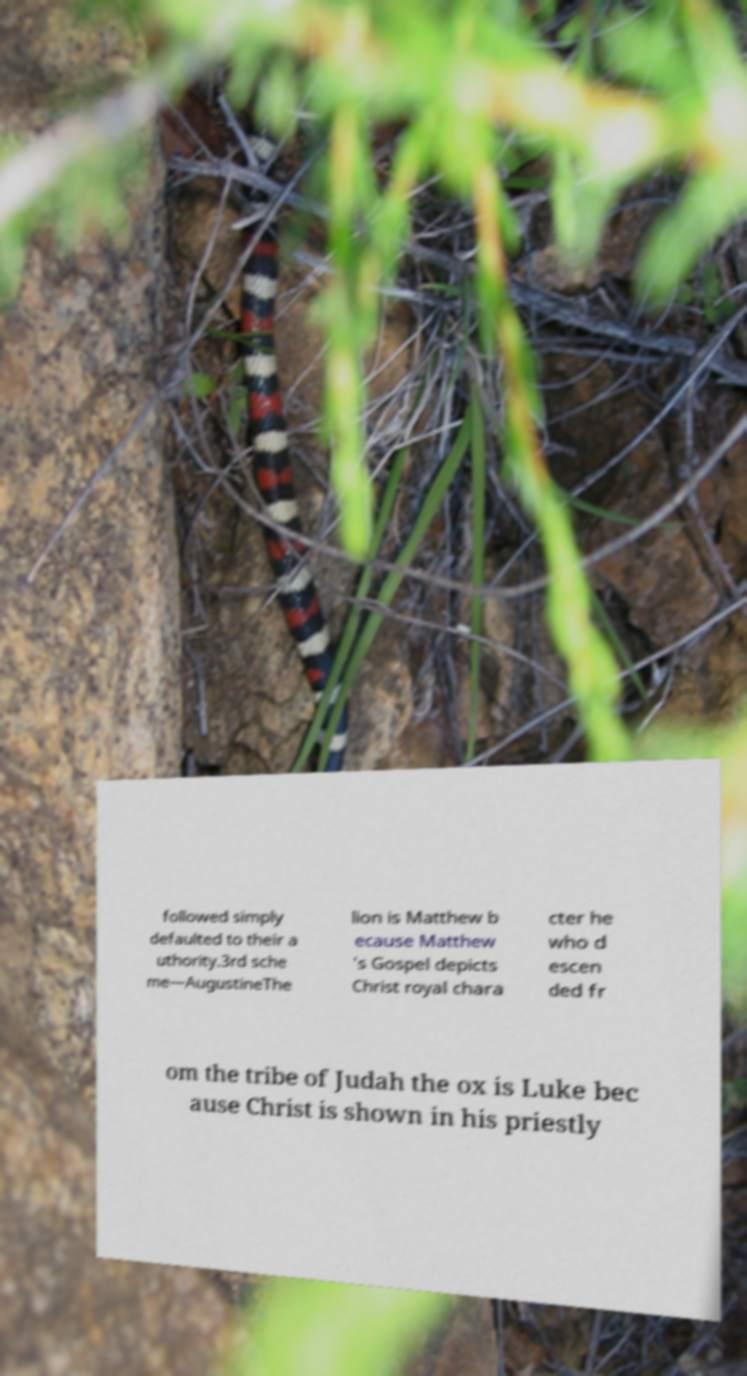Can you accurately transcribe the text from the provided image for me? followed simply defaulted to their a uthority.3rd sche me—AugustineThe lion is Matthew b ecause Matthew 's Gospel depicts Christ royal chara cter he who d escen ded fr om the tribe of Judah the ox is Luke bec ause Christ is shown in his priestly 